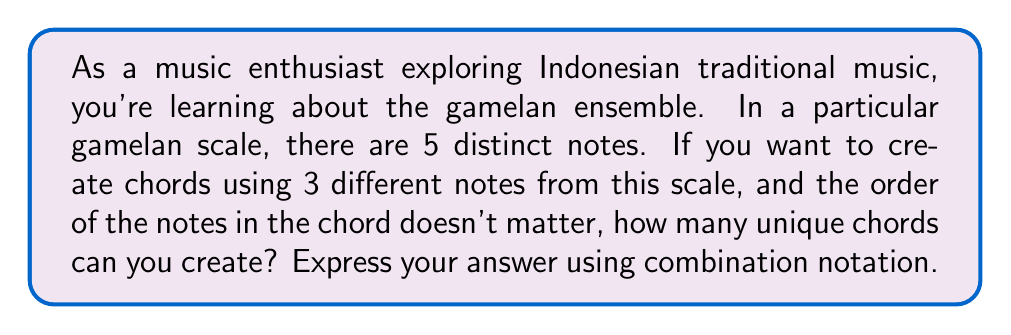Provide a solution to this math problem. Let's approach this step-by-step:

1) We are selecting 3 notes out of 5 available notes to form a chord.

2) The order of the notes doesn't matter. For example, a chord with notes A, B, and C is considered the same as B, C, and A.

3) We are not allowed to repeat notes in a chord.

4) This scenario describes a combination problem. We use the combination formula when we want to select items from a set without regard to order and without repetition.

5) The combination formula is:

   $$C(n,r) = \binom{n}{r} = \frac{n!}{r!(n-r)!}$$

   Where $n$ is the total number of items to choose from, and $r$ is the number of items being chosen.

6) In this case, $n = 5$ (total notes in the scale) and $r = 3$ (notes in each chord).

7) Plugging these values into the formula:

   $$C(5,3) = \binom{5}{3} = \frac{5!}{3!(5-3)!} = \frac{5!}{3!2!}$$

8) Expanding this:
   
   $$\frac{5 * 4 * 3!}{3! * 2 * 1} = \frac{20}{2} = 10$$

Therefore, you can create 10 unique chords.
Answer: $$\binom{5}{3} = 10$$ 